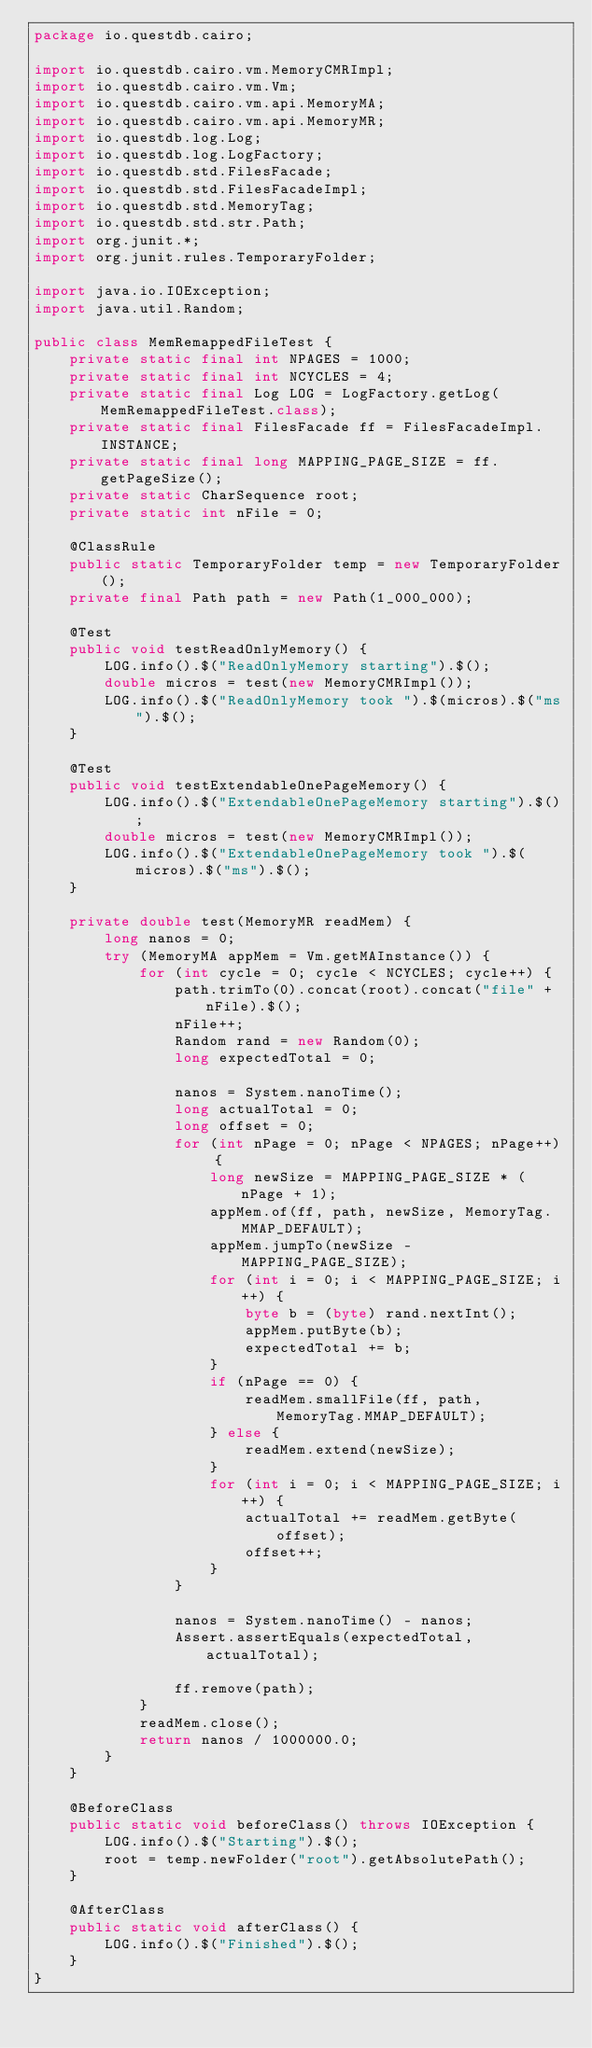Convert code to text. <code><loc_0><loc_0><loc_500><loc_500><_Java_>package io.questdb.cairo;

import io.questdb.cairo.vm.MemoryCMRImpl;
import io.questdb.cairo.vm.Vm;
import io.questdb.cairo.vm.api.MemoryMA;
import io.questdb.cairo.vm.api.MemoryMR;
import io.questdb.log.Log;
import io.questdb.log.LogFactory;
import io.questdb.std.FilesFacade;
import io.questdb.std.FilesFacadeImpl;
import io.questdb.std.MemoryTag;
import io.questdb.std.str.Path;
import org.junit.*;
import org.junit.rules.TemporaryFolder;

import java.io.IOException;
import java.util.Random;

public class MemRemappedFileTest {
    private static final int NPAGES = 1000;
    private static final int NCYCLES = 4;
    private static final Log LOG = LogFactory.getLog(MemRemappedFileTest.class);
    private static final FilesFacade ff = FilesFacadeImpl.INSTANCE;
    private static final long MAPPING_PAGE_SIZE = ff.getPageSize();
    private static CharSequence root;
    private static int nFile = 0;

    @ClassRule
    public static TemporaryFolder temp = new TemporaryFolder();
    private final Path path = new Path(1_000_000);

    @Test
    public void testReadOnlyMemory() {
        LOG.info().$("ReadOnlyMemory starting").$();
        double micros = test(new MemoryCMRImpl());
        LOG.info().$("ReadOnlyMemory took ").$(micros).$("ms").$();
    }

    @Test
    public void testExtendableOnePageMemory() {
        LOG.info().$("ExtendableOnePageMemory starting").$();
        double micros = test(new MemoryCMRImpl());
        LOG.info().$("ExtendableOnePageMemory took ").$(micros).$("ms").$();
    }

    private double test(MemoryMR readMem) {
        long nanos = 0;
        try (MemoryMA appMem = Vm.getMAInstance()) {
            for (int cycle = 0; cycle < NCYCLES; cycle++) {
                path.trimTo(0).concat(root).concat("file" + nFile).$();
                nFile++;
                Random rand = new Random(0);
                long expectedTotal = 0;

                nanos = System.nanoTime();
                long actualTotal = 0;
                long offset = 0;
                for (int nPage = 0; nPage < NPAGES; nPage++) {
                    long newSize = MAPPING_PAGE_SIZE * (nPage + 1);
                    appMem.of(ff, path, newSize, MemoryTag.MMAP_DEFAULT);
                    appMem.jumpTo(newSize - MAPPING_PAGE_SIZE);
                    for (int i = 0; i < MAPPING_PAGE_SIZE; i++) {
                        byte b = (byte) rand.nextInt();
                        appMem.putByte(b);
                        expectedTotal += b;
                    }
                    if (nPage == 0) {
                        readMem.smallFile(ff, path, MemoryTag.MMAP_DEFAULT);
                    } else {
                        readMem.extend(newSize);
                    }
                    for (int i = 0; i < MAPPING_PAGE_SIZE; i++) {
                        actualTotal += readMem.getByte(offset);
                        offset++;
                    }
                }

                nanos = System.nanoTime() - nanos;
                Assert.assertEquals(expectedTotal, actualTotal);

                ff.remove(path);
            }
            readMem.close();
            return nanos / 1000000.0;
        }
    }

    @BeforeClass
    public static void beforeClass() throws IOException {
        LOG.info().$("Starting").$();
        root = temp.newFolder("root").getAbsolutePath();
    }

    @AfterClass
    public static void afterClass() {
        LOG.info().$("Finished").$();
    }
}
</code> 